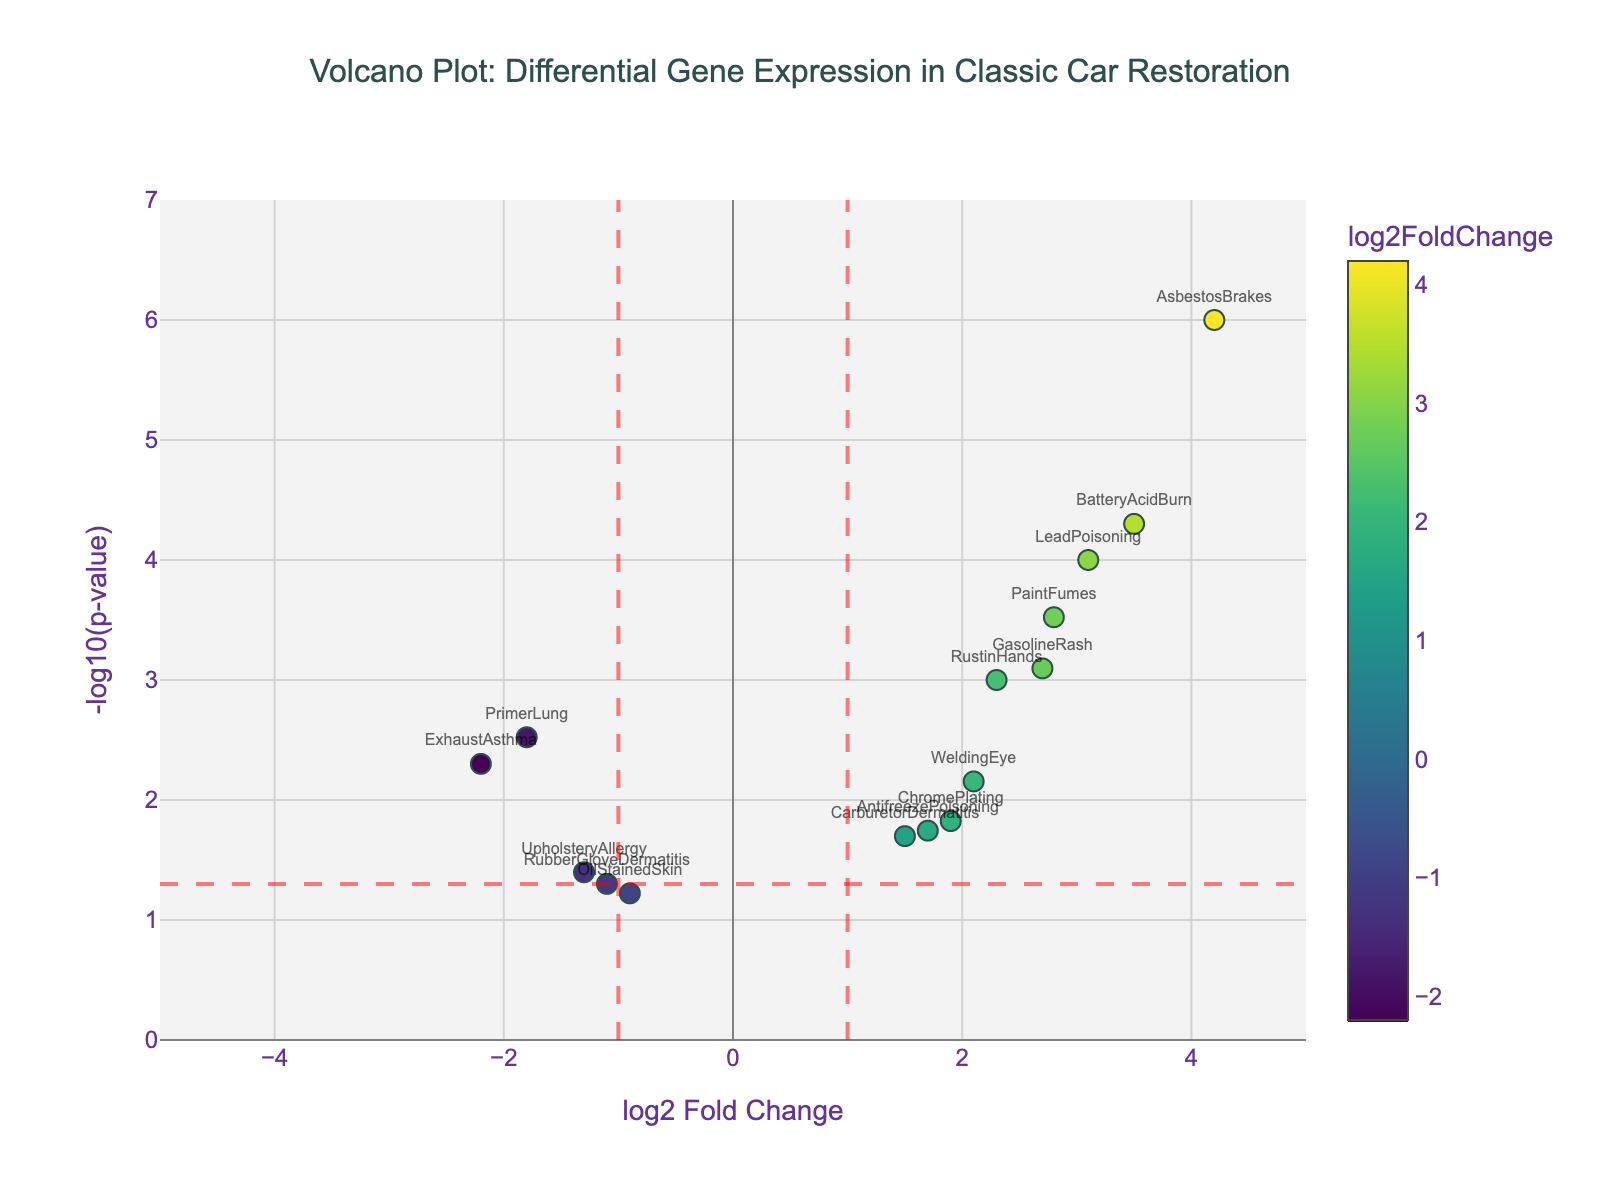How many genes are represented in the plot? The data table lists each gene by name, and each gene corresponds to a single marker in the plot. By counting the number of unique gene names, we find there are 15 genes on the plot.
Answer: 15 What's the basic trend indicated by the color of the data points? The color scale of the data points correlates with the log2 fold change values. Lighter colors indicate higher positive changes, whereas darker colors indicate lower or negative changes. Thus, genes with a high positive log2 fold change exhibit lighter colors, indicating increased expression levels.
Answer: Higher log2 fold change is lighter Which gene has the highest log2 fold change? By identifying the data point farthest to the right on the x-axis, we see that "AsbestosBrakes" has the highest log2 fold change, as confirmed by its position at log2FC = 4.2.
Answer: AsbestosBrakes Which gene has the lowest p-value? To find the gene with the lowest p-value, we look for the data point with the highest y-axis value, since -log10(p-value) is plotted on the y-axis. "AsbestosBrakes" is situated at the highest point, indicating it has the lowest p-value.
Answer: AsbestosBrakes How many genes have a log2 fold change greater than 1 and a p-value less than 0.05? By examining the plot, we need to count the number of data points to the right of the x=1 line (log2FC > 1) and above the y=-log10(0.05) line (-log10(pvalue) > 1.3). These genes are: "RustinHands," "LeadPoisoning," "GasolineRash," "BatteryAcidBurn," "WeldingEye," "PaintFumes," "AsbestosBrakes," and "ChromePlating."
Answer: 8 What is the p-value of "ChromePlating"? To find the p-value of "ChromePlating," locate its position on the plot and find its y-axis value. The y-axis value for "ChromePlating" is around 1.8, corresponding to a -log10(p-value). So, p-value = 10^(-1.8) ≈ 0.015
Answer: 0.015 What is the fold change for "ExhaustAsthma"? Locate "ExhaustAsthma" on the plot and read its x-coordinate, which corresponds to the log2 fold change. The value is -2.2, indicating a decrease in expression.
Answer: -2.2 Which gene has the smallest negative log2 fold change but is still significant (p-value < 0.05)? Identify the data point with the smallest negative x-value (log2 fold change) that is still left of the y=-log10(0.05) line. "PrimerLung" with log2FC = -1.8 and p-value = 0.003 fits this criterion.
Answer: PrimerLung 